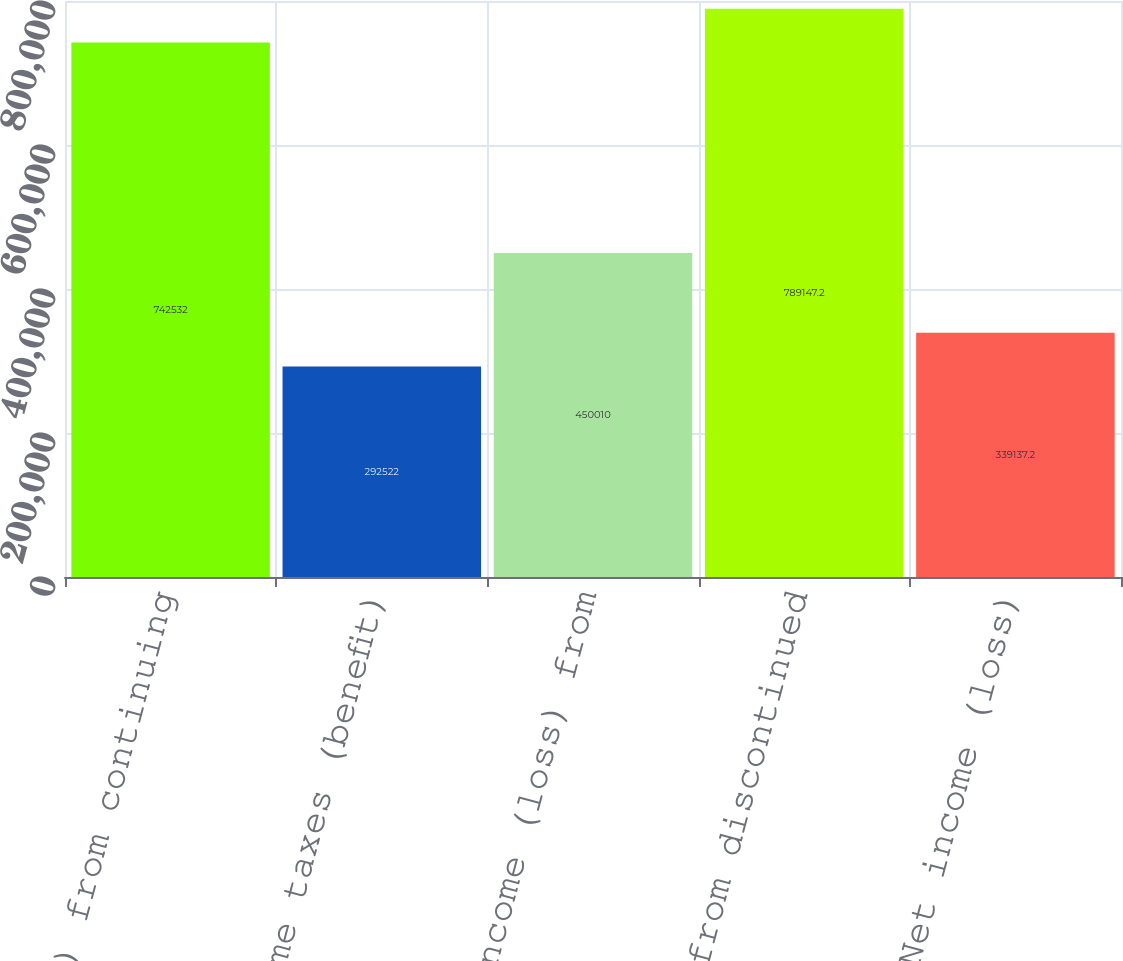<chart> <loc_0><loc_0><loc_500><loc_500><bar_chart><fcel>Income (loss) from continuing<fcel>Income taxes (benefit)<fcel>Net income (loss) from<fcel>Net loss from discontinued<fcel>Net income (loss)<nl><fcel>742532<fcel>292522<fcel>450010<fcel>789147<fcel>339137<nl></chart> 